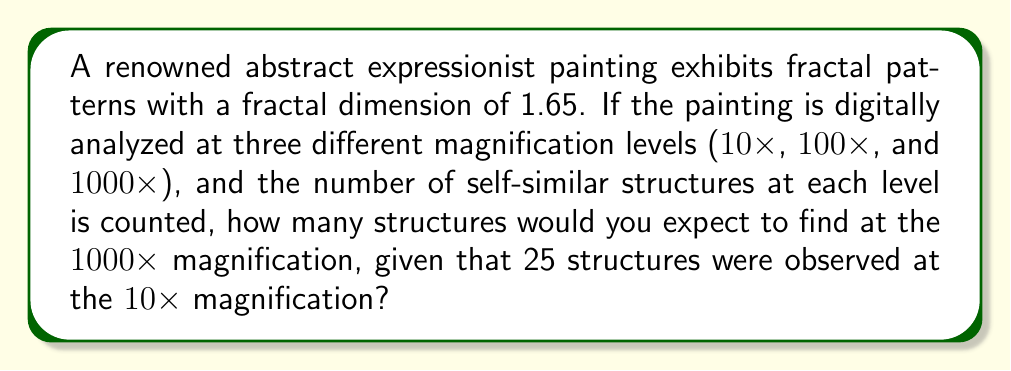Can you answer this question? To solve this problem, we need to use the concept of fractal dimension and the scaling relationship between different magnification levels. The fractal dimension $D$ is related to the number of self-similar structures $N$ and the scaling factor $r$ by the equation:

$$N = r^D$$

Let's approach this step-by-step:

1) We're given that the fractal dimension $D = 1.65$.

2) We have two magnification levels to compare: $10\times$ and $1000\times$. The scaling factor between these is:

   $$r = \frac{1000}{10} = 100$$

3) We know that at $10\times$ magnification, $N_1 = 25$ structures were observed.

4) Let $N_2$ be the number of structures at $1000\times$ magnification. We can set up the equation:

   $$\frac{N_2}{N_1} = r^D$$

5) Substituting the known values:

   $$\frac{N_2}{25} = 100^{1.65}$$

6) Solve for $N_2$:

   $$N_2 = 25 \times 100^{1.65}$$

7) Calculate:
   
   $$N_2 = 25 \times 10^{3.3} = 25 \times 1995.26 \approx 49881.5$$

8) Since we're counting discrete structures, we round to the nearest whole number.
Answer: Approximately 49,882 self-similar structures would be expected at the $1000\times$ magnification. 